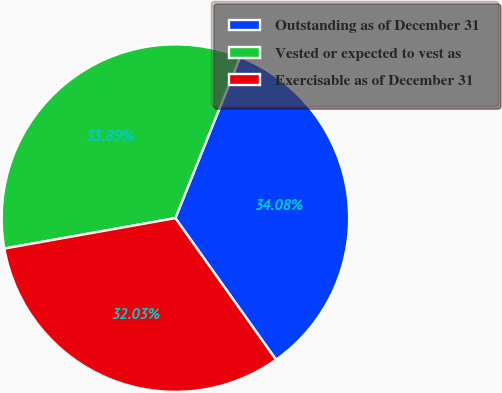Convert chart to OTSL. <chart><loc_0><loc_0><loc_500><loc_500><pie_chart><fcel>Outstanding as of December 31<fcel>Vested or expected to vest as<fcel>Exercisable as of December 31<nl><fcel>34.08%<fcel>33.89%<fcel>32.03%<nl></chart> 